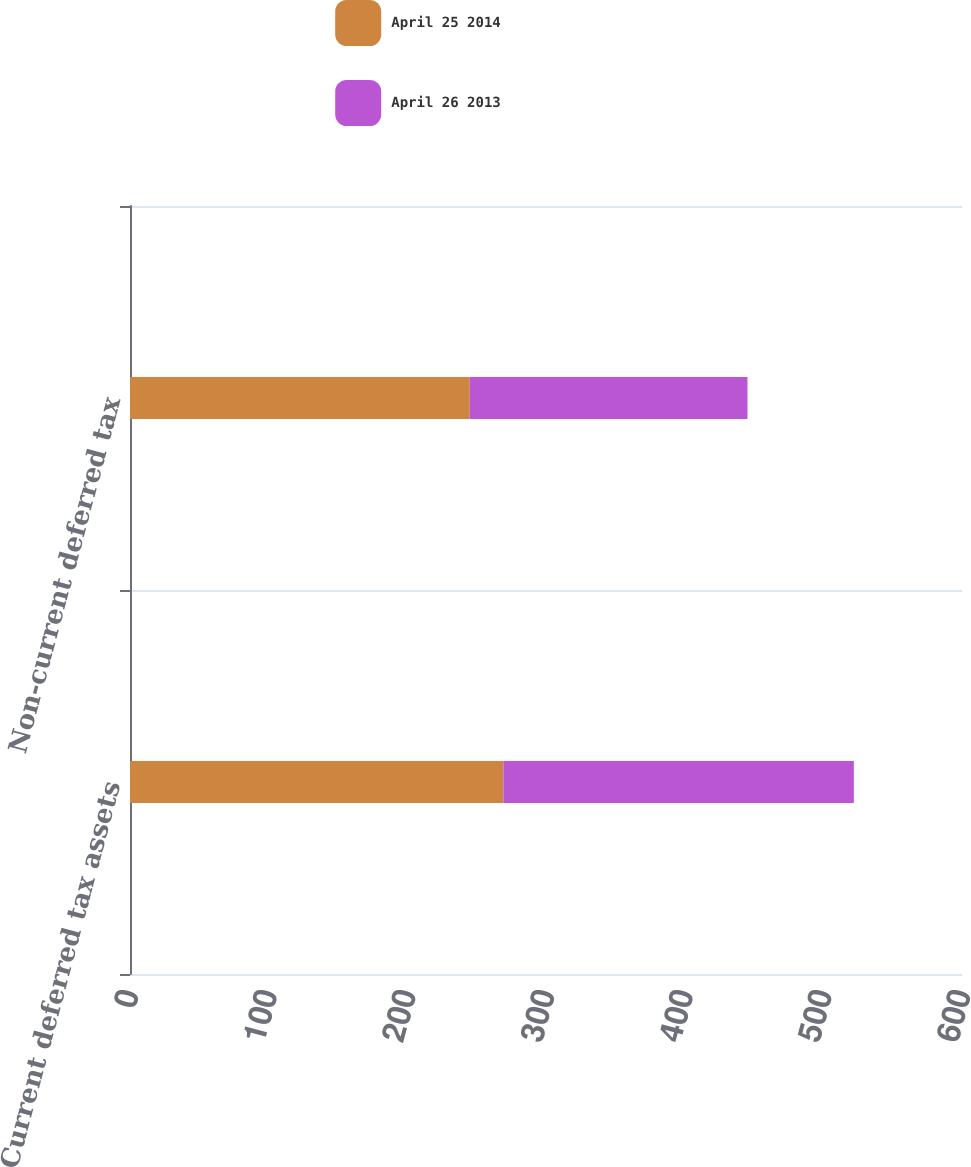Convert chart. <chart><loc_0><loc_0><loc_500><loc_500><stacked_bar_chart><ecel><fcel>Current deferred tax assets<fcel>Non-current deferred tax<nl><fcel>April 25 2014<fcel>269.3<fcel>245<nl><fcel>April 26 2013<fcel>252.7<fcel>200.3<nl></chart> 